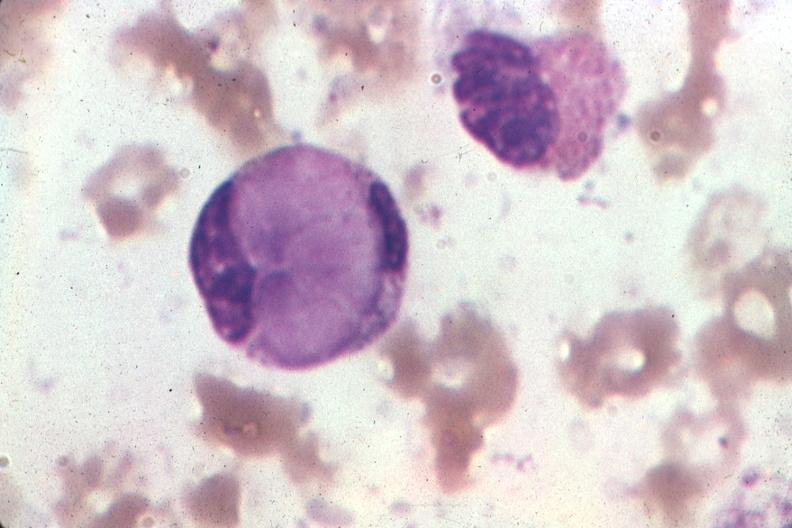what does this image show?
Answer the question using a single word or phrase. Wrights very good example 